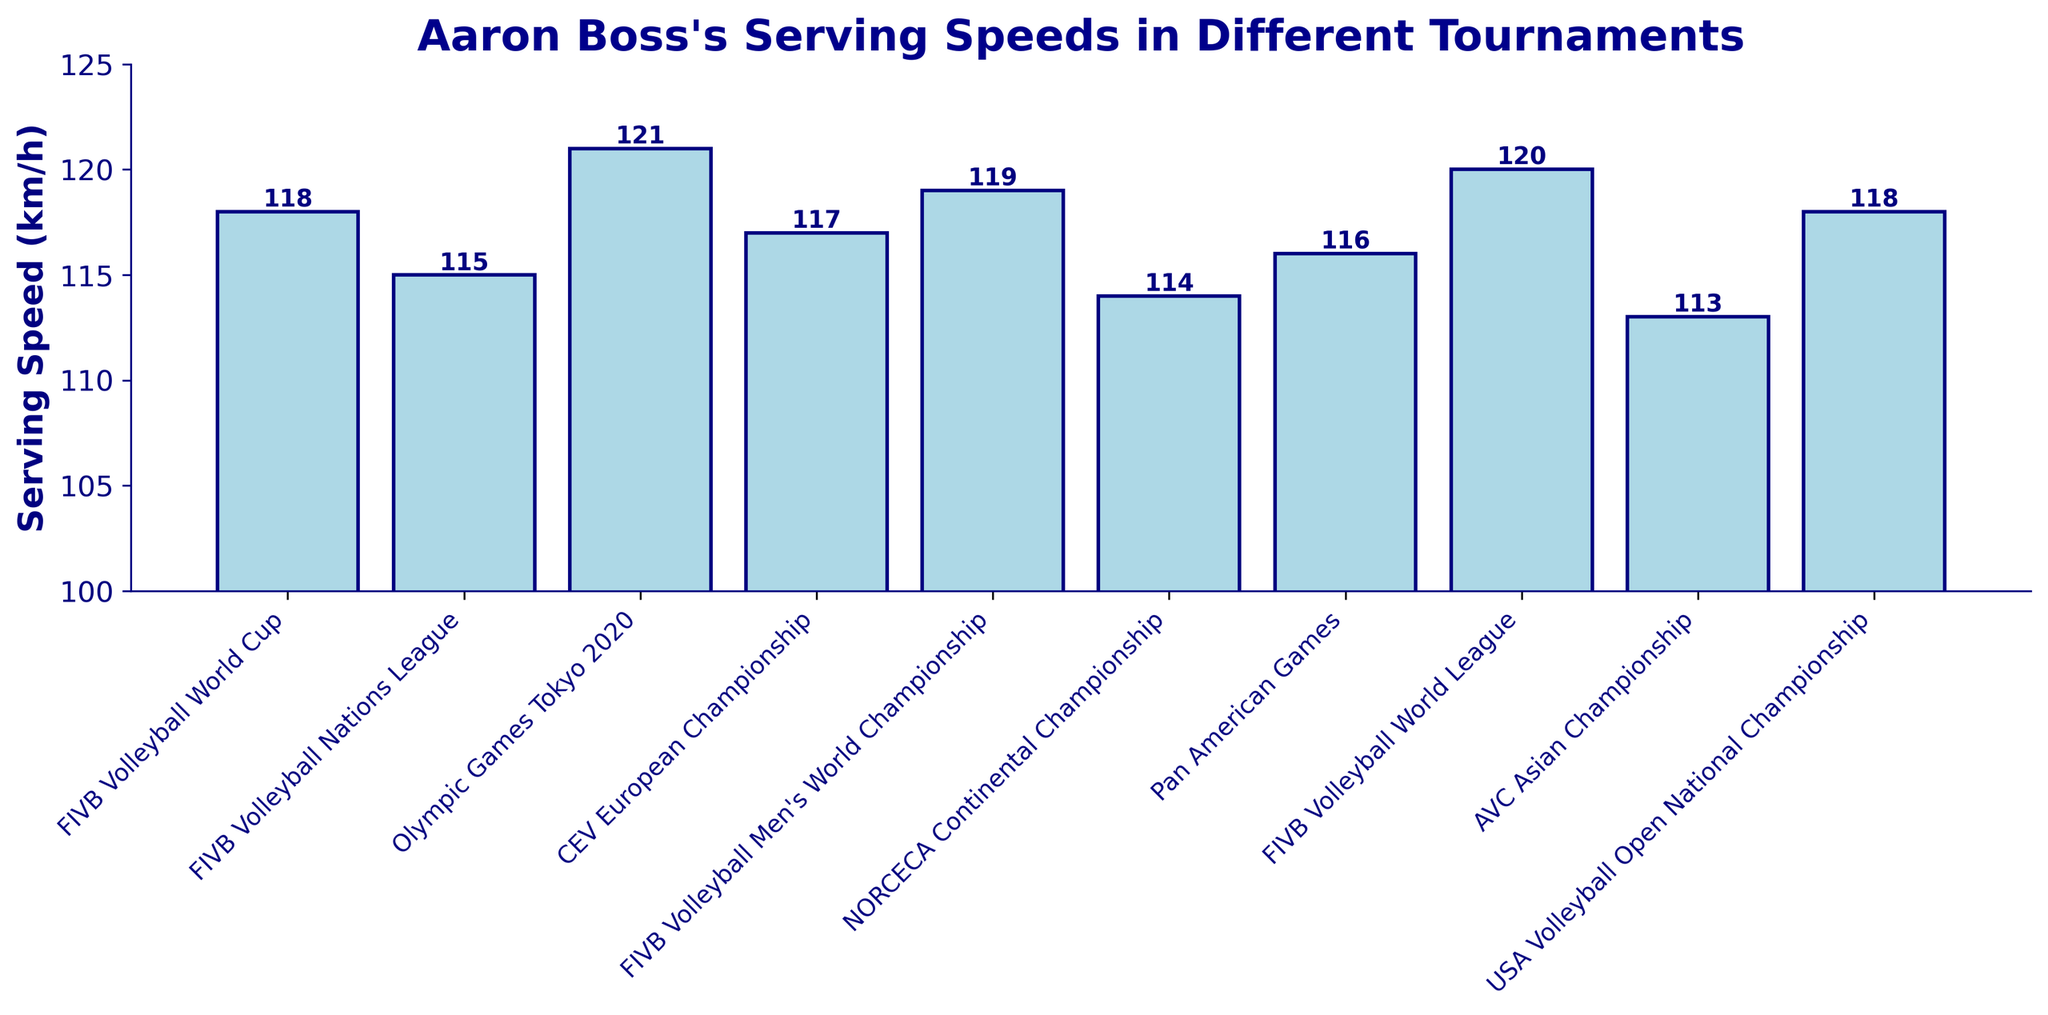Which tournament has the highest serving speed recorded for Aaron Boss? Look at the bar that reaches the highest point. The highest bar corresponds to the "Olympic Games Tokyo 2020" with a serving speed of 121 km/h.
Answer: Olympic Games Tokyo 2020 What is the difference in serving speeds between the FIVB Volleyball World Cup and the AVC Asian Championship? Subtract the serving speed of AVC Asian Championship (113 km/h) from that of the FIVB Volleyball World Cup (118 km/h). The difference is 118 - 113 = 5 km/h.
Answer: 5 km/h Which tournament has the lowest serving speed recorded for Aaron Boss? Identify the bar that is the shortest. The shortest bar corresponds to the "AVC Asian Championship" with a serving speed of 113 km/h.
Answer: AVC Asian Championship What is the average serving speed of Aaron Boss across all the tournaments? Sum the serving speeds (118, 115, 121, 117, 119, 114, 116, 120, 113, 118) and divide by the number of tournaments (10). The sum is 1171, and the average is 1171/10 = 117.1 km/h.
Answer: 117.1 km/h Are there any tournaments where Aaron Boss's serving speed is exactly equal to 120 km/h? Look for bars with a height labeled "120". The "FIVB Volleyball World League" has a serving speed of 120 km/h.
Answer: Yes, FIVB Volleyball World League How many tournaments have serving speeds greater than 118 km/h? Count the number of bars with heights greater than 118. These are the "Olympic Games Tokyo 2020" (121 km/h), "FIVB Volleyball Men's World Championship" (119 km/h), and "FIVB Volleyball World League" (120 km/h).
Answer: 3 What is the median serving speed of Aaron Boss across all tournaments? Order the serving speeds (113, 114, 115, 116, 117, 118, 118, 119, 120, 121). The median of an ordered dataset with an even number of values (10) is the average of the 5th and 6th values, which are both 118.
Answer: 118 km/h Which tournaments have serving speeds within 2 km/h of each other? Compare the serving speeds and identify pairs with differences of 2 km/h or less: 
- FIVB Volleyball World Cup (118) and USA Volleyball Open National Championship (118)
- Pan American Games (116) and CEV European Championship (117)
- FIVB Volleyball World Cup (118) and CEV European Championship (117)
Answer: FIVB Volleyball World Cup & USA Volleyball Open National Championship; Pan American Games & CEV European Championship; FIVB Volleyball World Cup & CEV European Championship 